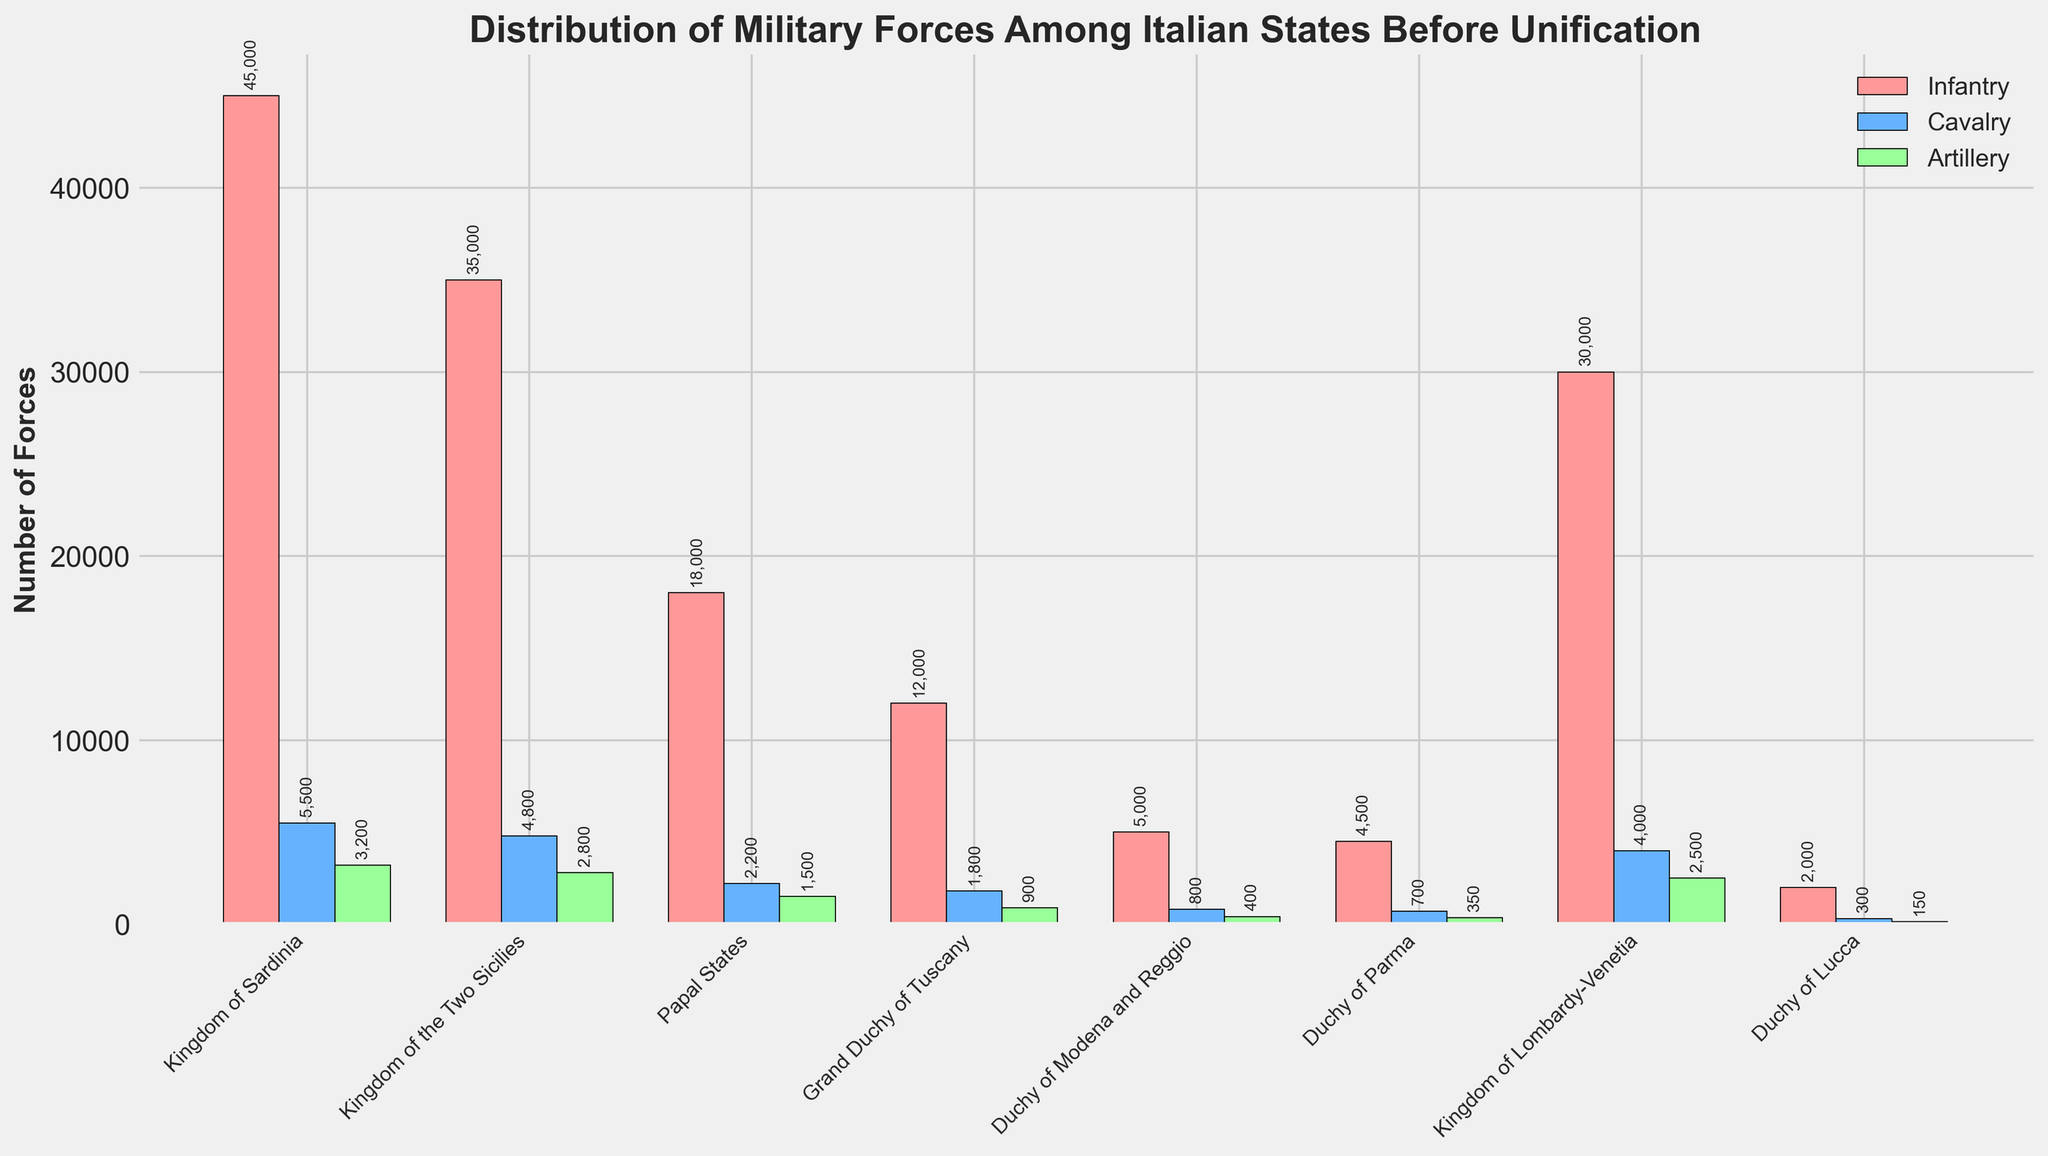Which state has the highest number of infantry forces? By reviewing the heights of the bars representing infantry forces, it is clear that the Kingdom of Sardinia has the tallest bar among the states.
Answer: Kingdom of Sardinia Which state has fewer artillery forces, the Duchy of Parma or the Duchy of Modena and Reggio? Comparing the heights of the green bars for both states shows that the Duchy of Parma has a shorter green bar than the Duchy of Modena and Reggio, indicating fewer artillery forces.
Answer: Duchy of Parma What is the total number of cavalry and artillery forces in the Papal States? First, identify the heights of the blue and green bars for the Papal States. The cavalry bar represents 2200 forces, and the artillery bar represents 1500 forces. Add these values together: 2200 + 1500 = 3700.
Answer: 3700 What is the difference in the number of infantry forces between the Kingdom of Sardinia and the Kingdom of Lombardy-Venetia? The infantry bar for the Kingdom of Sardinia shows 45000 forces, and the infantry bar for the Kingdom of Lombardy-Venetia shows 30000 forces. The difference is calculated as 45000 - 30000 = 15000.
Answer: 15000 Which state has the smallest overall number of military forces when totals for infantry, cavalry, and artillery are combined? Summing up the heights of red, blue, and green bars for each state shows that the Duchy of Lucca has the smallest combined total: 2000 (infantry) + 300 (cavalry) + 150 (artillery) = 2450.
Answer: Duchy of Lucca Are there any states where the number of cavalry exceeds the number of artillery forces? By comparing the heights of the blue and green bars for each state, the Kingdom of Sardinia, Kingdom of the Two Sicilies, Papal States, Grand Duchy of Tuscany, Duchy of Modena and Reggio, Duchy of Parma, Kingdom of Lombardy-Venetia, and Duchy of Lucca all have taller blue bars (cavalry) than green bars (artillery).
Answer: Yes What is the average number of infantry forces among all the states? To find the average, sum all the infantry forces: 45000 (Sardinia) + 35000 (Two Sicilies) + 18000 (Papal States) + 12000 (Tuscany) + 5000 (Modena and Reggio) + 4500 (Parma) + 30000 (Lombardy-Venetia) + 2000 (Lucca) = 151500. Now, divide by the number of states (8): 151500 / 8 = 18937.5.
Answer: 18937.5 Which state has the most balanced distribution of military forces, looking at the height of the bars for infantry, cavalry, and artillery being relatively similar? By examining the height differences between the red, blue, and green bars for each state, the Grand Duchy of Tuscany seems to have the most balanced distribution, with infantry at 12000, cavalry at 1800, and artillery at 900.
Answer: Grand Duchy of Tuscany 